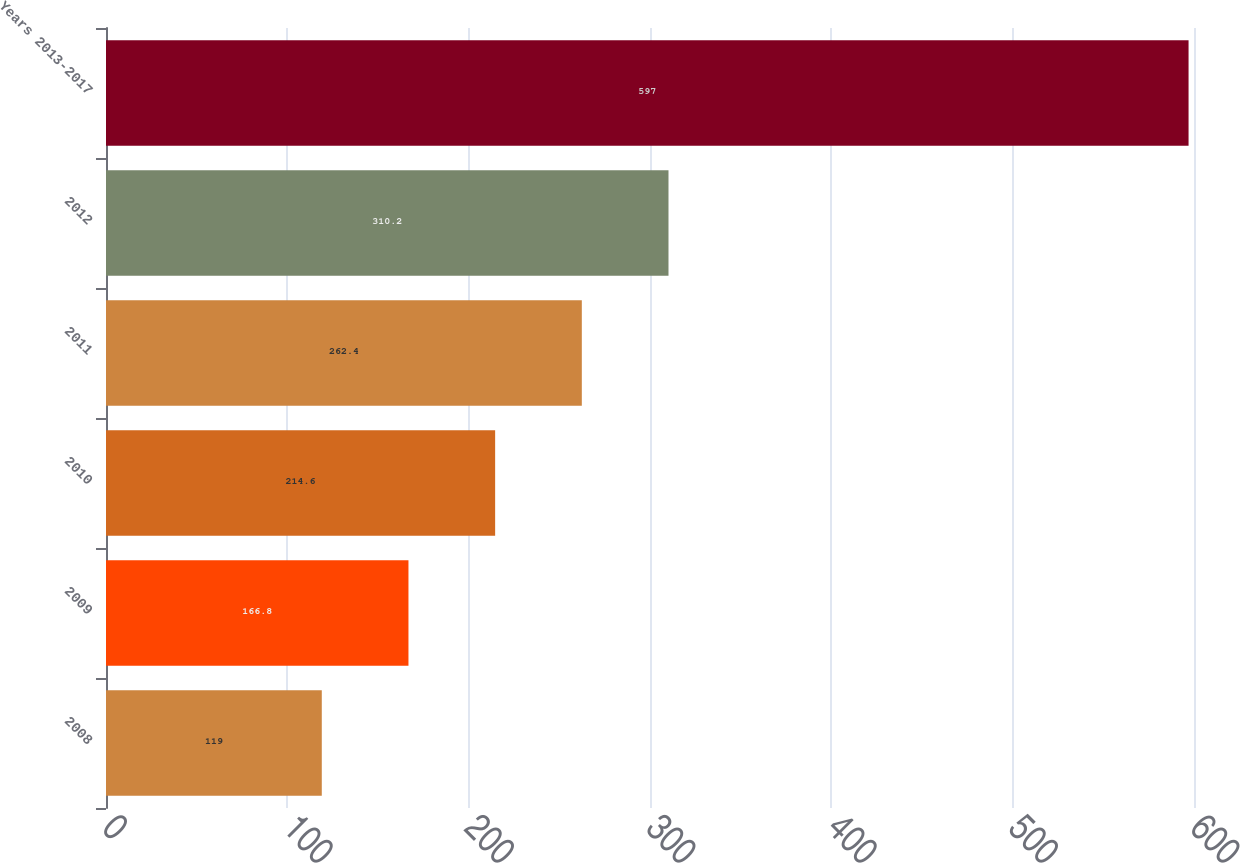<chart> <loc_0><loc_0><loc_500><loc_500><bar_chart><fcel>2008<fcel>2009<fcel>2010<fcel>2011<fcel>2012<fcel>Years 2013-2017<nl><fcel>119<fcel>166.8<fcel>214.6<fcel>262.4<fcel>310.2<fcel>597<nl></chart> 